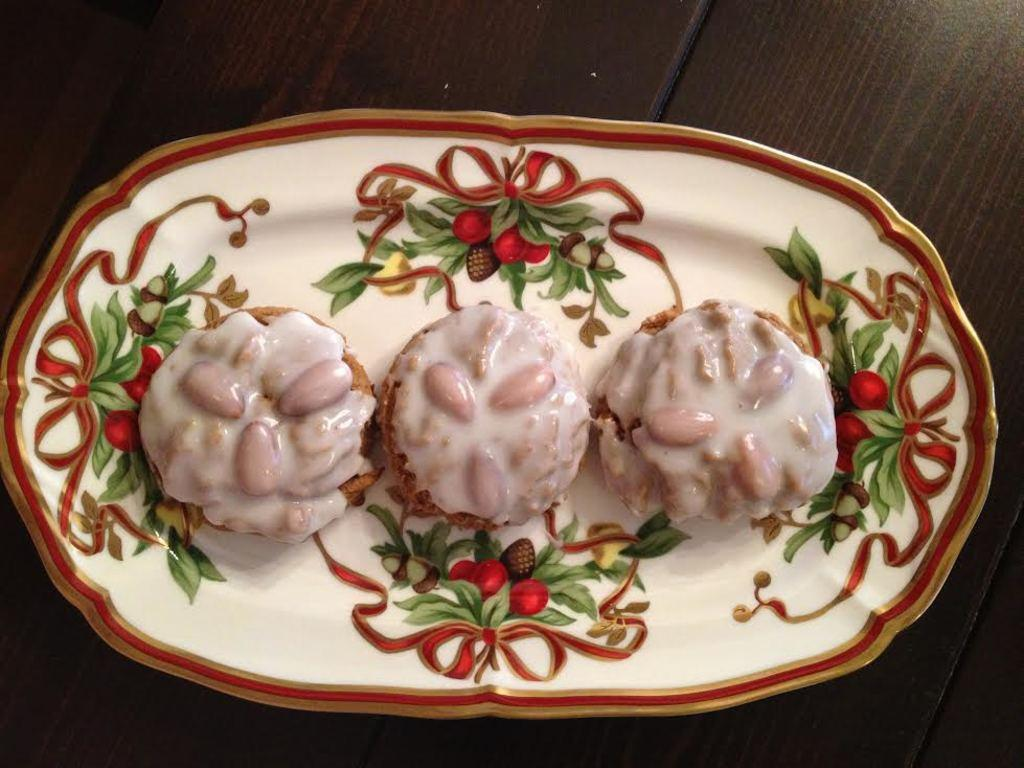What is present in the image related to food? There is food in the image. How is the food arranged or presented? The food is on a colorful plate. What colors can be seen in the food? The food has white and brown colors. What is the color of the table the plate is on? The plate is on a brown and black table. What type of stretch can be seen in the image? There is no stretch present in the image; it features food on a plate. Can you describe the duck in the image? There is no duck present in the image. 